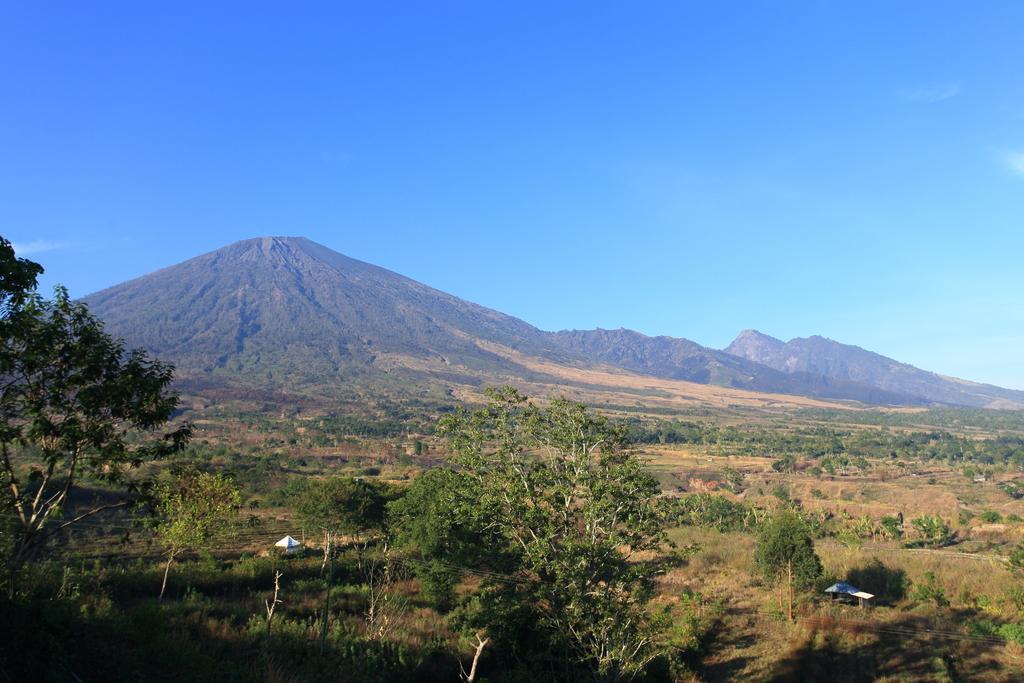Could you give a brief overview of what you see in this image? This picture is clicked outside the city. In the foreground we can see the plants and trees and some other objects. In the background there is a sky and the hills. 